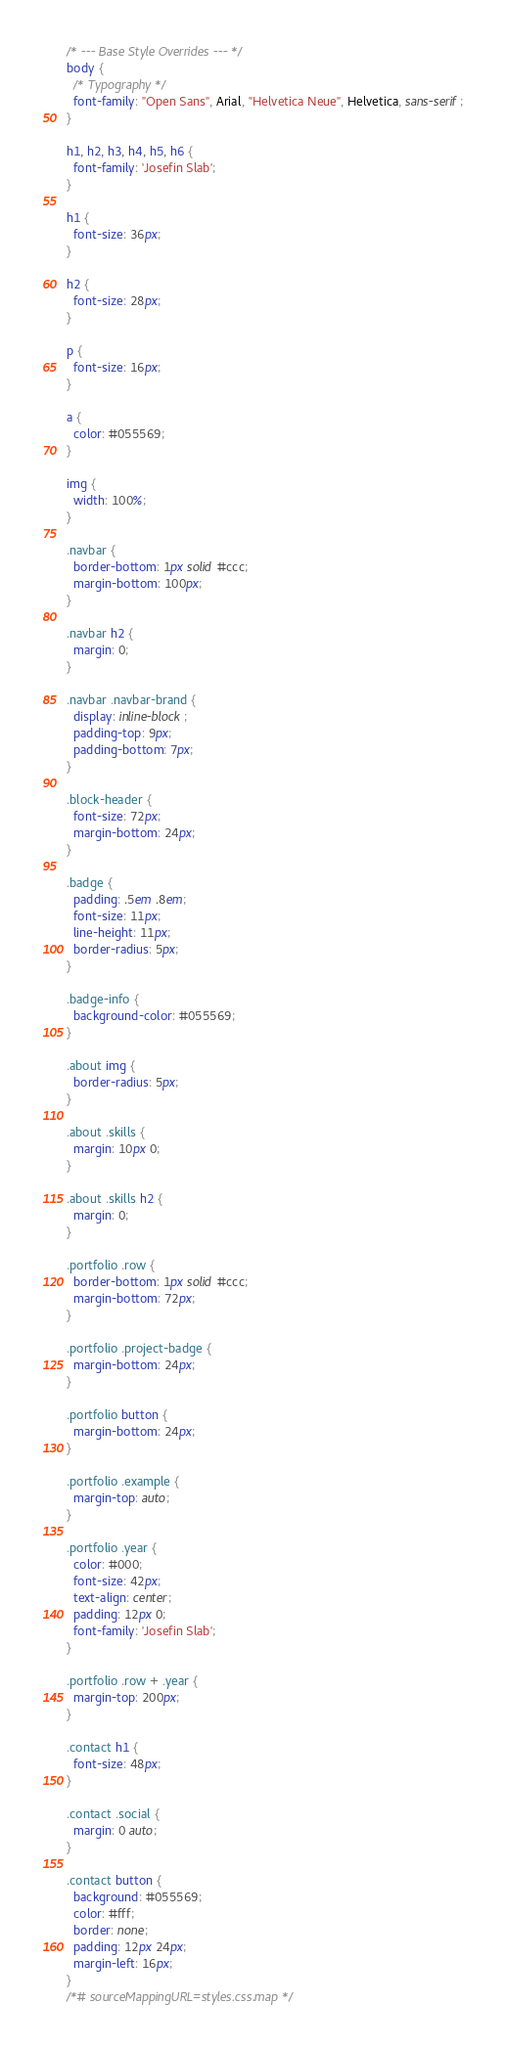Convert code to text. <code><loc_0><loc_0><loc_500><loc_500><_CSS_>/* --- Base Style Overrides --- */
body {
  /* Typography */
  font-family: "Open Sans", Arial, "Helvetica Neue", Helvetica, sans-serif;
}

h1, h2, h3, h4, h5, h6 {
  font-family: 'Josefin Slab';
}

h1 {
  font-size: 36px;
}

h2 {
  font-size: 28px;
}

p {
  font-size: 16px;
}

a {
  color: #055569;
}

img {
  width: 100%;
}

.navbar {
  border-bottom: 1px solid #ccc;
  margin-bottom: 100px;
}

.navbar h2 {
  margin: 0;
}

.navbar .navbar-brand {
  display: inline-block;
  padding-top: 9px;
  padding-bottom: 7px;
}

.block-header {
  font-size: 72px;
  margin-bottom: 24px;
}

.badge {
  padding: .5em .8em;
  font-size: 11px;
  line-height: 11px;
  border-radius: 5px;
}

.badge-info {
  background-color: #055569;
}

.about img {
  border-radius: 5px;
}

.about .skills {
  margin: 10px 0;
}

.about .skills h2 {
  margin: 0;
}

.portfolio .row {
  border-bottom: 1px solid #ccc;
  margin-bottom: 72px;
}

.portfolio .project-badge {
  margin-bottom: 24px;
}

.portfolio button {
  margin-bottom: 24px;
}

.portfolio .example {
  margin-top: auto;
}

.portfolio .year {
  color: #000;
  font-size: 42px;
  text-align: center;
  padding: 12px 0;
  font-family: 'Josefin Slab';
}

.portfolio .row + .year {
  margin-top: 200px;
}

.contact h1 {
  font-size: 48px;
}

.contact .social {
  margin: 0 auto;
}

.contact button {
  background: #055569;
  color: #fff;
  border: none;
  padding: 12px 24px;
  margin-left: 16px;
}
/*# sourceMappingURL=styles.css.map */</code> 